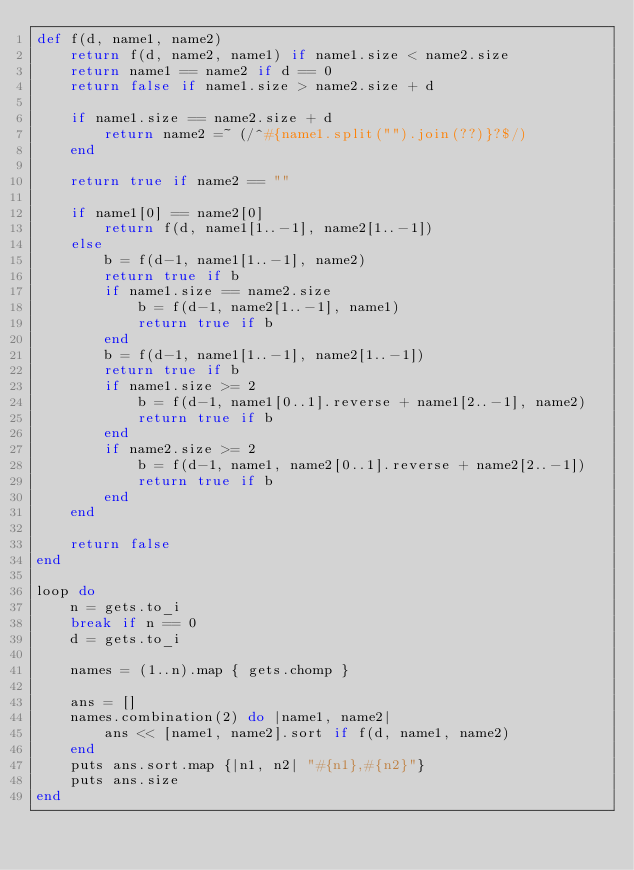Convert code to text. <code><loc_0><loc_0><loc_500><loc_500><_Ruby_>def f(d, name1, name2)
    return f(d, name2, name1) if name1.size < name2.size
    return name1 == name2 if d == 0
    return false if name1.size > name2.size + d

    if name1.size == name2.size + d
        return name2 =~ (/^#{name1.split("").join(??)}?$/)
    end

    return true if name2 == ""

    if name1[0] == name2[0]
        return f(d, name1[1..-1], name2[1..-1])
    else
        b = f(d-1, name1[1..-1], name2)
        return true if b
        if name1.size == name2.size
            b = f(d-1, name2[1..-1], name1)
            return true if b
        end
        b = f(d-1, name1[1..-1], name2[1..-1])
        return true if b
        if name1.size >= 2
            b = f(d-1, name1[0..1].reverse + name1[2..-1], name2)
            return true if b
        end
        if name2.size >= 2
            b = f(d-1, name1, name2[0..1].reverse + name2[2..-1])
            return true if b
        end
    end
    
    return false
end

loop do
    n = gets.to_i
    break if n == 0
    d = gets.to_i
    
    names = (1..n).map { gets.chomp }

    ans = []
    names.combination(2) do |name1, name2|
        ans << [name1, name2].sort if f(d, name1, name2)
    end
    puts ans.sort.map {|n1, n2| "#{n1},#{n2}"}
    puts ans.size
end</code> 